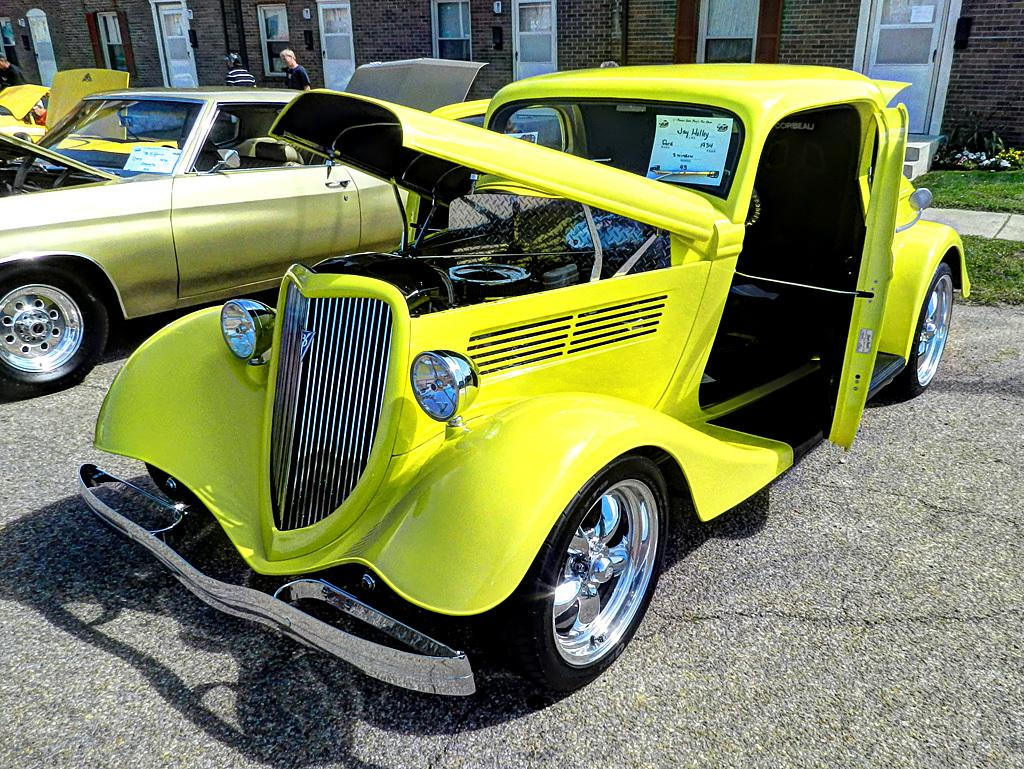What can be seen on the road in the image? There are cars of different colors on the road. What is visible in the background of the image? There are houses, doors, people, and other objects in the background of the image. What type of apple can be seen in the image? There is no apple present in the image. Is there any crime happening in the image? There is no indication of any crime in the image. 